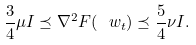<formula> <loc_0><loc_0><loc_500><loc_500>\frac { 3 } { 4 } \mu I \preceq \nabla ^ { 2 } F ( \ w _ { t } ) \preceq \frac { 5 } { 4 } \nu I .</formula> 